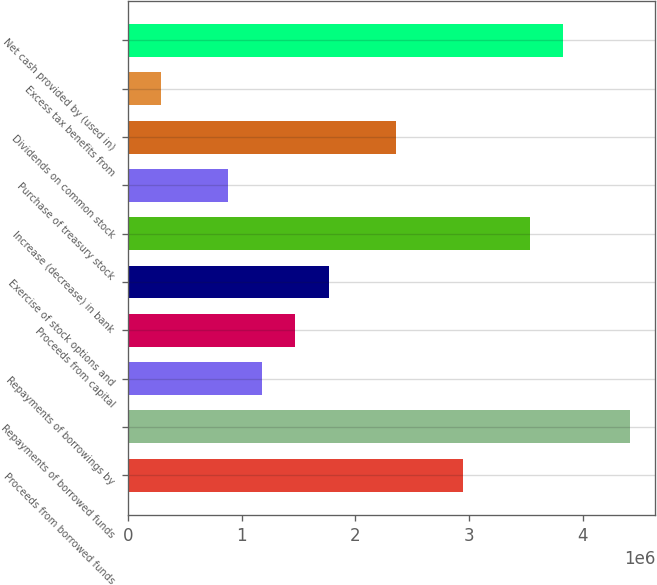Convert chart to OTSL. <chart><loc_0><loc_0><loc_500><loc_500><bar_chart><fcel>Proceeds from borrowed funds<fcel>Repayments of borrowed funds<fcel>Repayments of borrowings by<fcel>Proceeds from capital<fcel>Exercise of stock options and<fcel>Increase (decrease) in bank<fcel>Purchase of treasury stock<fcel>Dividends on common stock<fcel>Excess tax benefits from<fcel>Net cash provided by (used in)<nl><fcel>2.94324e+06<fcel>4.41445e+06<fcel>1.17779e+06<fcel>1.47203e+06<fcel>1.76627e+06<fcel>3.53172e+06<fcel>883548<fcel>2.35476e+06<fcel>295066<fcel>3.82596e+06<nl></chart> 